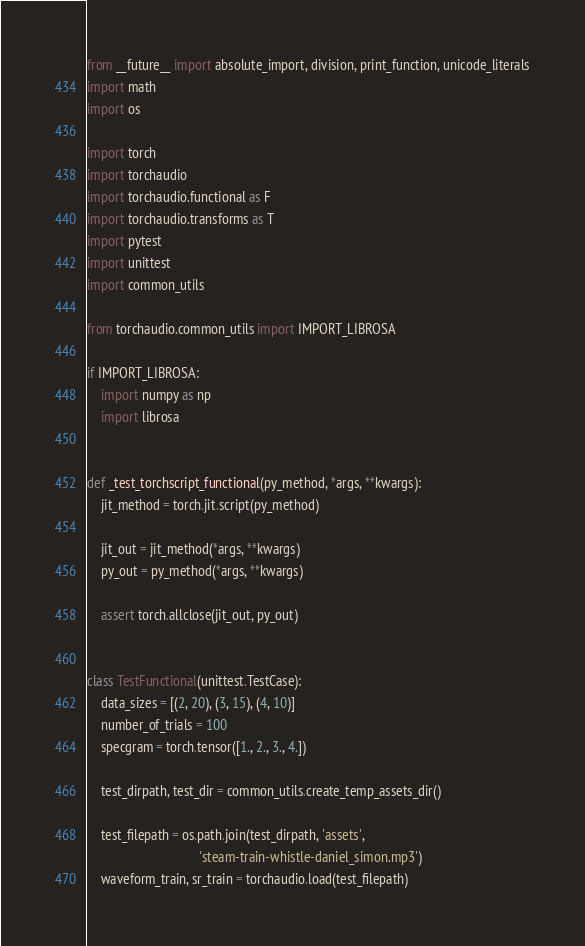<code> <loc_0><loc_0><loc_500><loc_500><_Python_>from __future__ import absolute_import, division, print_function, unicode_literals
import math
import os

import torch
import torchaudio
import torchaudio.functional as F
import torchaudio.transforms as T
import pytest
import unittest
import common_utils

from torchaudio.common_utils import IMPORT_LIBROSA

if IMPORT_LIBROSA:
    import numpy as np
    import librosa


def _test_torchscript_functional(py_method, *args, **kwargs):
    jit_method = torch.jit.script(py_method)

    jit_out = jit_method(*args, **kwargs)
    py_out = py_method(*args, **kwargs)

    assert torch.allclose(jit_out, py_out)


class TestFunctional(unittest.TestCase):
    data_sizes = [(2, 20), (3, 15), (4, 10)]
    number_of_trials = 100
    specgram = torch.tensor([1., 2., 3., 4.])

    test_dirpath, test_dir = common_utils.create_temp_assets_dir()

    test_filepath = os.path.join(test_dirpath, 'assets',
                                 'steam-train-whistle-daniel_simon.mp3')
    waveform_train, sr_train = torchaudio.load(test_filepath)
</code> 